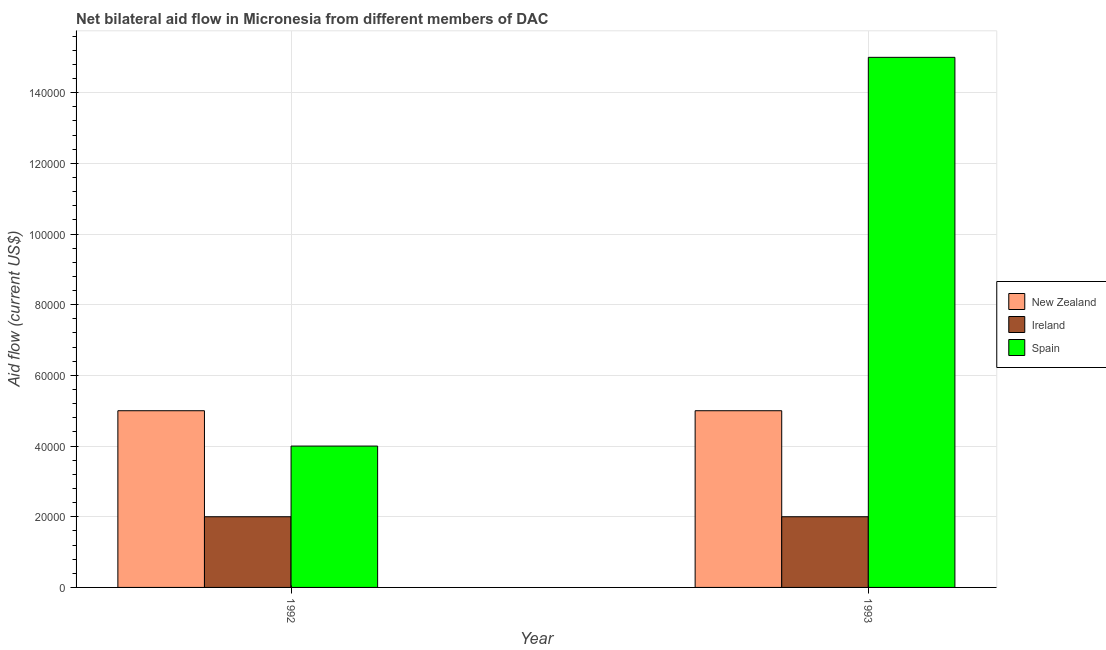Are the number of bars per tick equal to the number of legend labels?
Offer a very short reply. Yes. Are the number of bars on each tick of the X-axis equal?
Give a very brief answer. Yes. How many bars are there on the 1st tick from the left?
Keep it short and to the point. 3. How many bars are there on the 1st tick from the right?
Make the answer very short. 3. In how many cases, is the number of bars for a given year not equal to the number of legend labels?
Offer a terse response. 0. What is the amount of aid provided by ireland in 1993?
Offer a very short reply. 2.00e+04. Across all years, what is the maximum amount of aid provided by new zealand?
Provide a succinct answer. 5.00e+04. Across all years, what is the minimum amount of aid provided by spain?
Provide a short and direct response. 4.00e+04. In which year was the amount of aid provided by new zealand maximum?
Give a very brief answer. 1992. In which year was the amount of aid provided by ireland minimum?
Give a very brief answer. 1992. What is the total amount of aid provided by spain in the graph?
Keep it short and to the point. 1.90e+05. What is the difference between the amount of aid provided by spain in 1992 and that in 1993?
Provide a short and direct response. -1.10e+05. What is the difference between the amount of aid provided by spain in 1993 and the amount of aid provided by ireland in 1992?
Your response must be concise. 1.10e+05. What is the average amount of aid provided by spain per year?
Provide a succinct answer. 9.50e+04. In the year 1993, what is the difference between the amount of aid provided by ireland and amount of aid provided by new zealand?
Offer a terse response. 0. What is the ratio of the amount of aid provided by ireland in 1992 to that in 1993?
Make the answer very short. 1. Is the amount of aid provided by spain in 1992 less than that in 1993?
Your answer should be very brief. Yes. In how many years, is the amount of aid provided by new zealand greater than the average amount of aid provided by new zealand taken over all years?
Keep it short and to the point. 0. What does the 3rd bar from the right in 1993 represents?
Provide a succinct answer. New Zealand. Are all the bars in the graph horizontal?
Your answer should be very brief. No. What is the difference between two consecutive major ticks on the Y-axis?
Your answer should be very brief. 2.00e+04. Are the values on the major ticks of Y-axis written in scientific E-notation?
Provide a short and direct response. No. Does the graph contain any zero values?
Your answer should be compact. No. Does the graph contain grids?
Give a very brief answer. Yes. How many legend labels are there?
Ensure brevity in your answer.  3. What is the title of the graph?
Make the answer very short. Net bilateral aid flow in Micronesia from different members of DAC. What is the label or title of the X-axis?
Offer a terse response. Year. What is the Aid flow (current US$) in Ireland in 1992?
Keep it short and to the point. 2.00e+04. What is the Aid flow (current US$) in Spain in 1992?
Provide a succinct answer. 4.00e+04. Across all years, what is the maximum Aid flow (current US$) of New Zealand?
Provide a succinct answer. 5.00e+04. Across all years, what is the maximum Aid flow (current US$) of Spain?
Provide a short and direct response. 1.50e+05. Across all years, what is the minimum Aid flow (current US$) in New Zealand?
Ensure brevity in your answer.  5.00e+04. Across all years, what is the minimum Aid flow (current US$) of Spain?
Offer a very short reply. 4.00e+04. What is the difference between the Aid flow (current US$) in Ireland in 1992 and that in 1993?
Your answer should be very brief. 0. What is the difference between the Aid flow (current US$) in Spain in 1992 and that in 1993?
Your answer should be compact. -1.10e+05. What is the difference between the Aid flow (current US$) of Ireland in 1992 and the Aid flow (current US$) of Spain in 1993?
Offer a very short reply. -1.30e+05. What is the average Aid flow (current US$) in New Zealand per year?
Provide a succinct answer. 5.00e+04. What is the average Aid flow (current US$) of Spain per year?
Provide a short and direct response. 9.50e+04. In the year 1992, what is the difference between the Aid flow (current US$) of New Zealand and Aid flow (current US$) of Spain?
Your answer should be very brief. 10000. In the year 1992, what is the difference between the Aid flow (current US$) of Ireland and Aid flow (current US$) of Spain?
Keep it short and to the point. -2.00e+04. In the year 1993, what is the difference between the Aid flow (current US$) in New Zealand and Aid flow (current US$) in Ireland?
Your answer should be very brief. 3.00e+04. What is the ratio of the Aid flow (current US$) in Ireland in 1992 to that in 1993?
Make the answer very short. 1. What is the ratio of the Aid flow (current US$) in Spain in 1992 to that in 1993?
Keep it short and to the point. 0.27. What is the difference between the highest and the lowest Aid flow (current US$) of Spain?
Your answer should be very brief. 1.10e+05. 